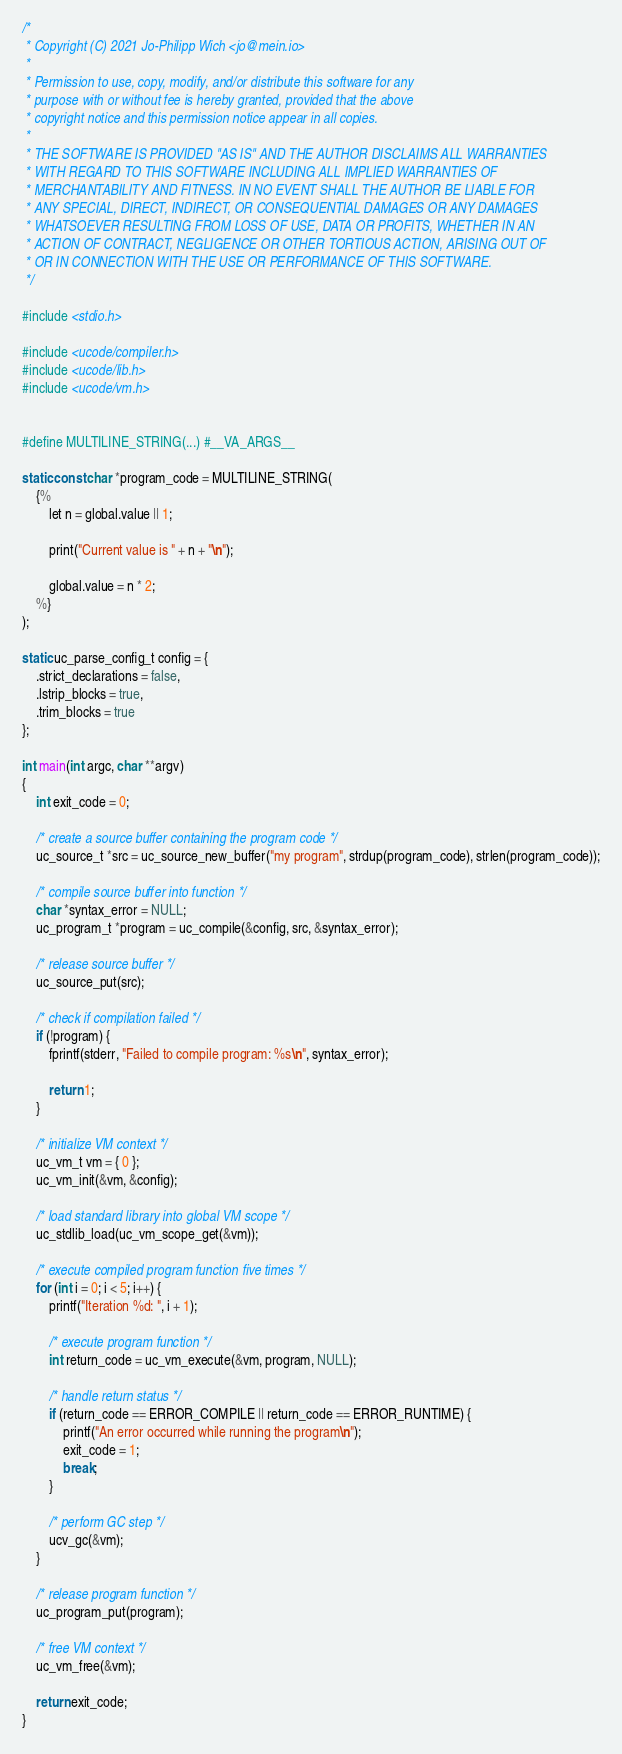<code> <loc_0><loc_0><loc_500><loc_500><_C_>/*
 * Copyright (C) 2021 Jo-Philipp Wich <jo@mein.io>
 *
 * Permission to use, copy, modify, and/or distribute this software for any
 * purpose with or without fee is hereby granted, provided that the above
 * copyright notice and this permission notice appear in all copies.
 *
 * THE SOFTWARE IS PROVIDED "AS IS" AND THE AUTHOR DISCLAIMS ALL WARRANTIES
 * WITH REGARD TO THIS SOFTWARE INCLUDING ALL IMPLIED WARRANTIES OF
 * MERCHANTABILITY AND FITNESS. IN NO EVENT SHALL THE AUTHOR BE LIABLE FOR
 * ANY SPECIAL, DIRECT, INDIRECT, OR CONSEQUENTIAL DAMAGES OR ANY DAMAGES
 * WHATSOEVER RESULTING FROM LOSS OF USE, DATA OR PROFITS, WHETHER IN AN
 * ACTION OF CONTRACT, NEGLIGENCE OR OTHER TORTIOUS ACTION, ARISING OUT OF
 * OR IN CONNECTION WITH THE USE OR PERFORMANCE OF THIS SOFTWARE.
 */

#include <stdio.h>

#include <ucode/compiler.h>
#include <ucode/lib.h>
#include <ucode/vm.h>


#define MULTILINE_STRING(...) #__VA_ARGS__

static const char *program_code = MULTILINE_STRING(
	{%
		let n = global.value || 1;

		print("Current value is " + n + "\n");

		global.value = n * 2;
	%}
);

static uc_parse_config_t config = {
	.strict_declarations = false,
	.lstrip_blocks = true,
	.trim_blocks = true
};

int main(int argc, char **argv)
{
	int exit_code = 0;

	/* create a source buffer containing the program code */
	uc_source_t *src = uc_source_new_buffer("my program", strdup(program_code), strlen(program_code));

	/* compile source buffer into function */
	char *syntax_error = NULL;
	uc_program_t *program = uc_compile(&config, src, &syntax_error);

	/* release source buffer */
	uc_source_put(src);

	/* check if compilation failed */
	if (!program) {
		fprintf(stderr, "Failed to compile program: %s\n", syntax_error);

		return 1;
	}

	/* initialize VM context */
	uc_vm_t vm = { 0 };
	uc_vm_init(&vm, &config);

	/* load standard library into global VM scope */
	uc_stdlib_load(uc_vm_scope_get(&vm));

	/* execute compiled program function five times */
	for (int i = 0; i < 5; i++) {
		printf("Iteration %d: ", i + 1);

		/* execute program function */
		int return_code = uc_vm_execute(&vm, program, NULL);

		/* handle return status */
		if (return_code == ERROR_COMPILE || return_code == ERROR_RUNTIME) {
			printf("An error occurred while running the program\n");
			exit_code = 1;
			break;
		}

		/* perform GC step */
		ucv_gc(&vm);
	}

	/* release program function */
	uc_program_put(program);

	/* free VM context */
	uc_vm_free(&vm);

	return exit_code;
}
</code> 